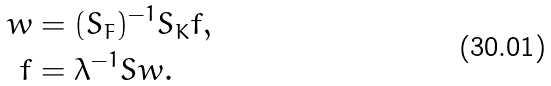Convert formula to latex. <formula><loc_0><loc_0><loc_500><loc_500>w & = ( S _ { F } ) ^ { - 1 } S _ { K } f , \\ f & = \lambda ^ { - 1 } S w .</formula> 